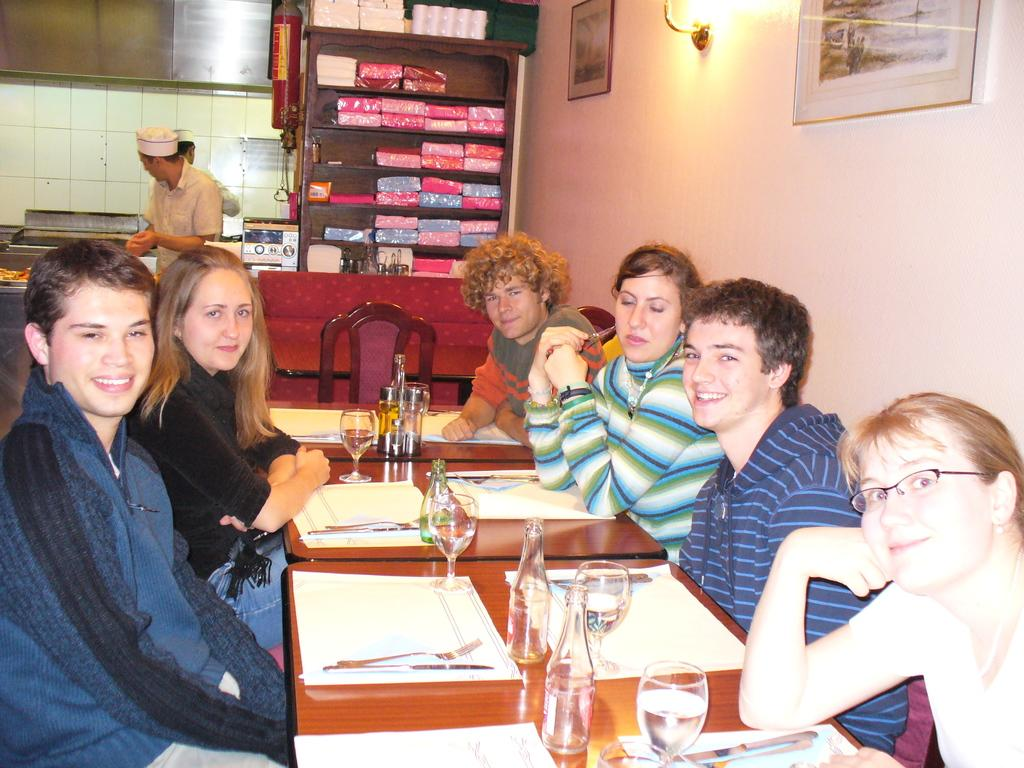What are the people in the image doing? The people in the image are sitting around a table. What items can be seen on the table? The table has glasses and bottles on it. What is visible on the shelf in the image? The shelf contains cloth packs. What type of soda is being served in the glasses on the table? There is no indication of the type of beverage in the glasses, and soda is not mentioned in the provided facts. Is there a chicken on the table or shelf in the image? No, there is no chicken present in the image. 